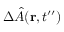<formula> <loc_0><loc_0><loc_500><loc_500>\Delta \hat { A } ( { r } , t ^ { \prime \prime } )</formula> 